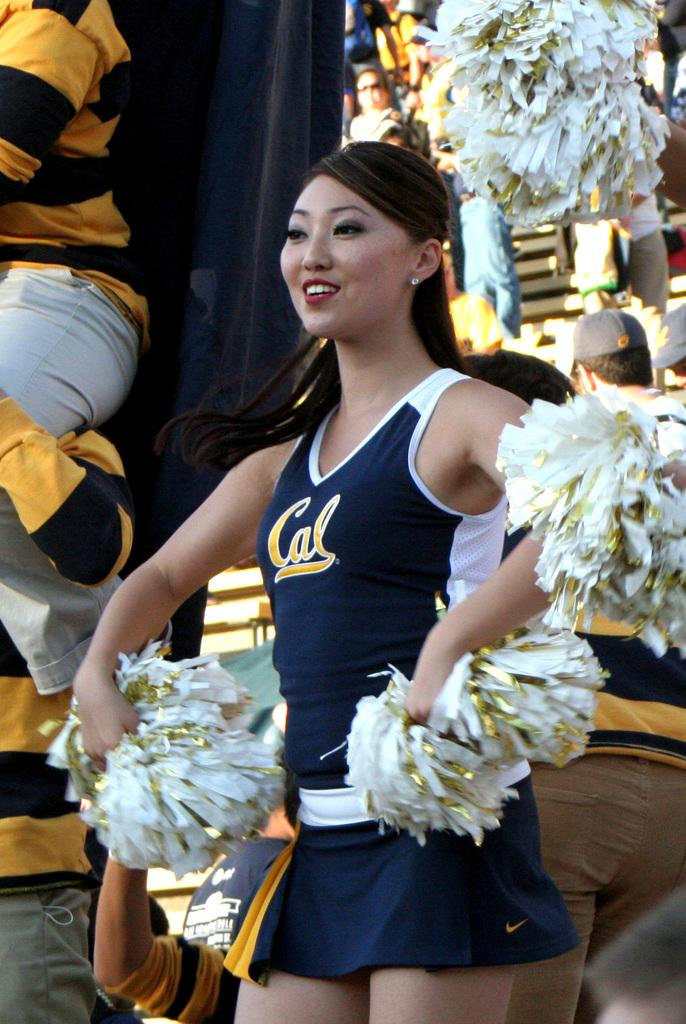<image>
Present a compact description of the photo's key features. Cheerleader with pom poms in hand wearing Cal jersey. 